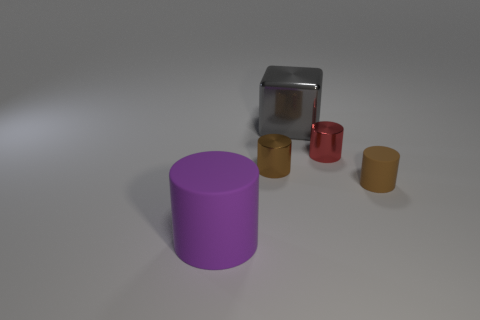Add 2 tiny brown cylinders. How many objects exist? 7 Subtract all cubes. How many objects are left? 4 Subtract 0 brown balls. How many objects are left? 5 Subtract all small cyan rubber cubes. Subtract all small metal cylinders. How many objects are left? 3 Add 5 tiny red cylinders. How many tiny red cylinders are left? 6 Add 1 red things. How many red things exist? 2 